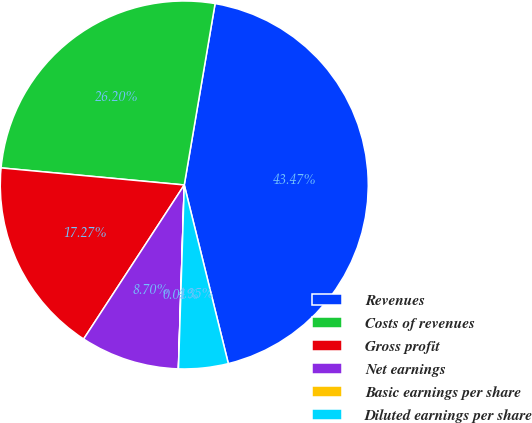<chart> <loc_0><loc_0><loc_500><loc_500><pie_chart><fcel>Revenues<fcel>Costs of revenues<fcel>Gross profit<fcel>Net earnings<fcel>Basic earnings per share<fcel>Diluted earnings per share<nl><fcel>43.47%<fcel>26.2%<fcel>17.27%<fcel>8.7%<fcel>0.01%<fcel>4.35%<nl></chart> 